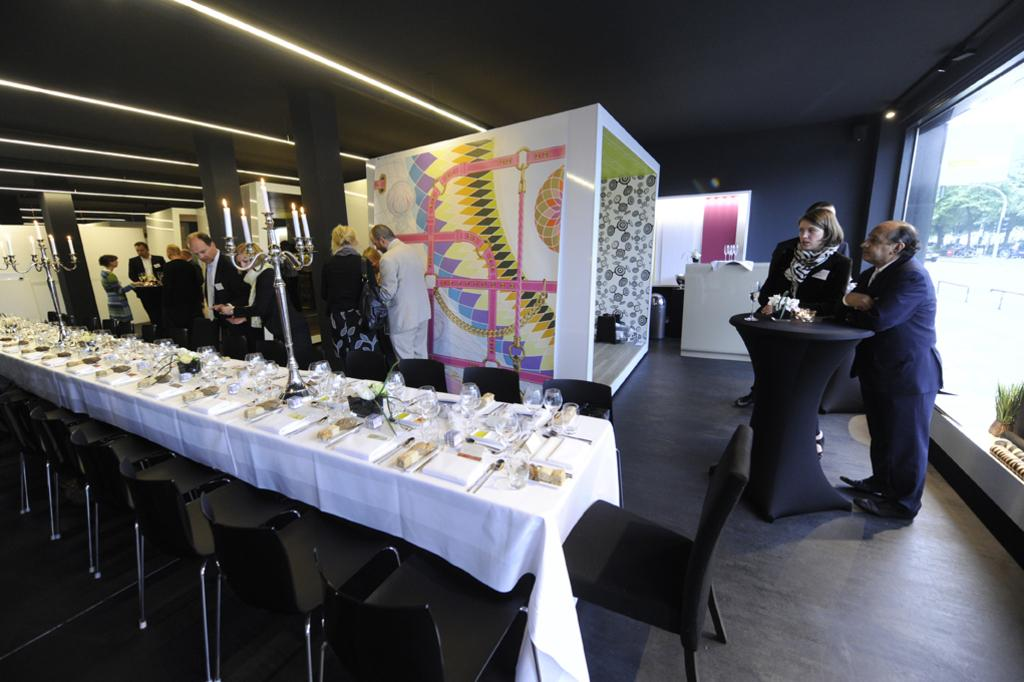How many people are in the image? There is a group of people in the image, but the exact number is not specified. What are the people in the image doing? The people are standing in the image. What type of event is taking place in the image? The setting is a party, which suggests a social gathering. Where is the party being held? The party is taking place in a hall. What type of adjustment is being made to the hammer in the image? There is no hammer present in the image, so no adjustment can be made. 